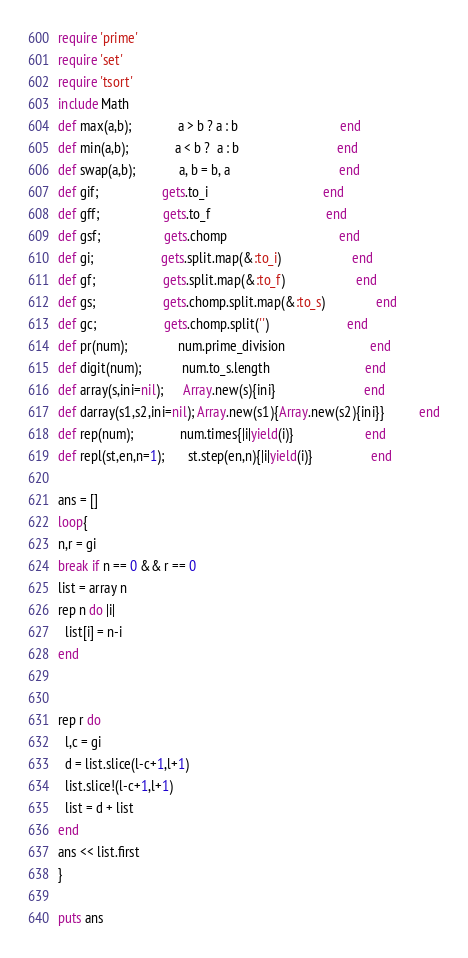<code> <loc_0><loc_0><loc_500><loc_500><_Ruby_>require 'prime'
require 'set'
require 'tsort'
include Math
def max(a,b);              a > b ? a : b                              end
def min(a,b);              a < b ?  a : b                             end
def swap(a,b);             a, b = b, a                                end
def gif;                   gets.to_i                                  end
def gff;                   gets.to_f                                  end
def gsf;                   gets.chomp                                 end
def gi;                    gets.split.map(&:to_i)                     end
def gf;                    gets.split.map(&:to_f)                     end
def gs;                    gets.chomp.split.map(&:to_s)               end
def gc;                    gets.chomp.split('')                       end
def pr(num);               num.prime_division                         end
def digit(num);            num.to_s.length                            end
def array(s,ini=nil);      Array.new(s){ini}                          end
def darray(s1,s2,ini=nil); Array.new(s1){Array.new(s2){ini}}          end
def rep(num);              num.times{|i|yield(i)}                     end
def repl(st,en,n=1);       st.step(en,n){|i|yield(i)}                 end

ans = []
loop{
n,r = gi
break if n == 0 && r == 0
list = array n
rep n do |i|
  list[i] = n-i
end


rep r do
  l,c = gi
  d = list.slice(l-c+1,l+1)
  list.slice!(l-c+1,l+1)
  list = d + list
end
ans << list.first
}

puts ans</code> 